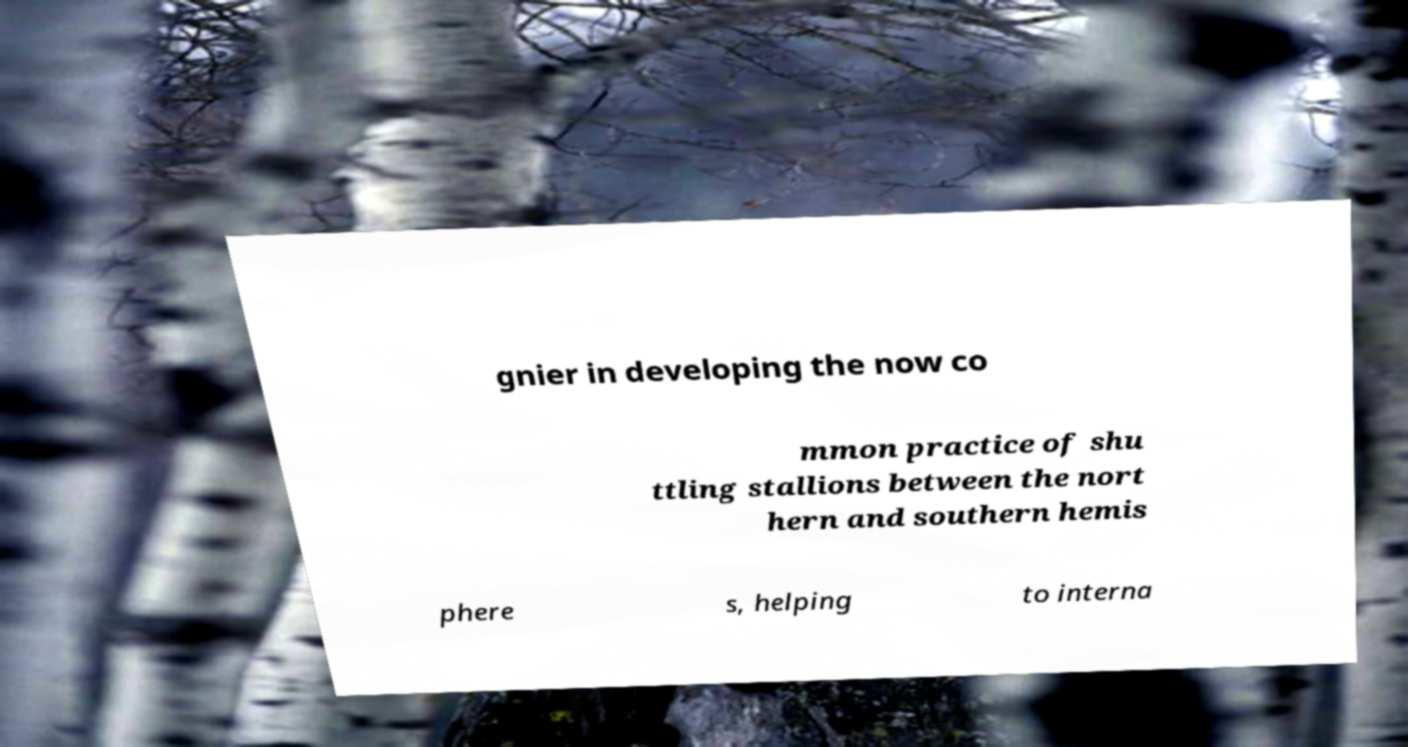For documentation purposes, I need the text within this image transcribed. Could you provide that? gnier in developing the now co mmon practice of shu ttling stallions between the nort hern and southern hemis phere s, helping to interna 